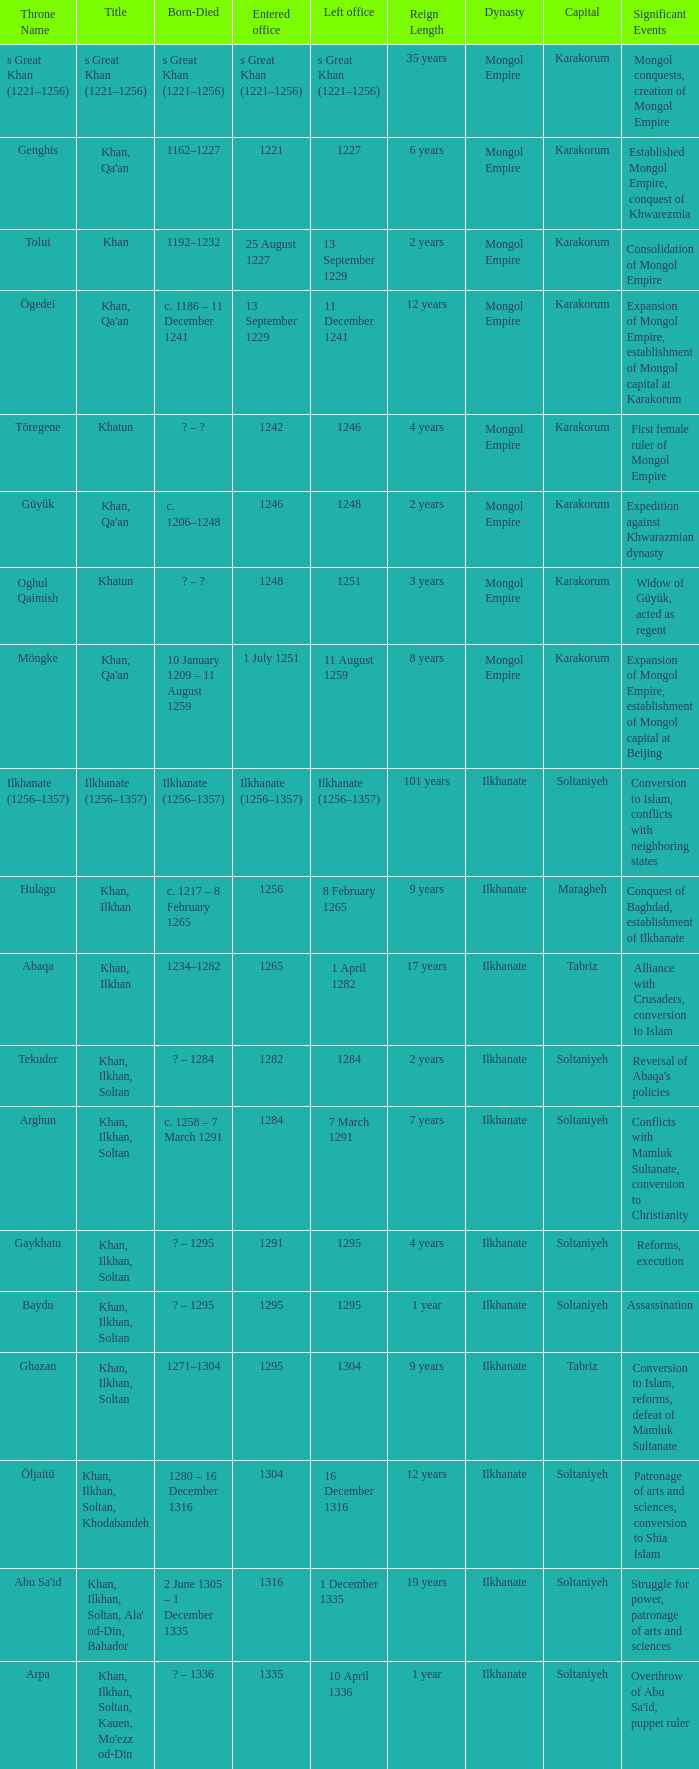What is the born-died that has office of 13 September 1229 as the entered? C. 1186 – 11 december 1241. 